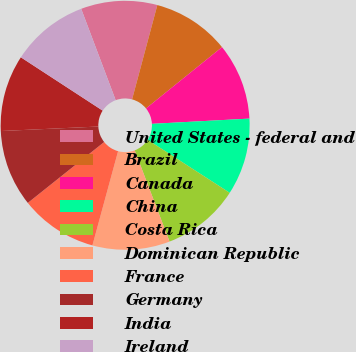<chart> <loc_0><loc_0><loc_500><loc_500><pie_chart><fcel>United States - federal and<fcel>Brazil<fcel>Canada<fcel>China<fcel>Costa Rica<fcel>Dominican Republic<fcel>France<fcel>Germany<fcel>India<fcel>Ireland<nl><fcel>9.91%<fcel>10.03%<fcel>9.95%<fcel>9.98%<fcel>10.07%<fcel>10.04%<fcel>10.05%<fcel>9.98%<fcel>9.93%<fcel>10.06%<nl></chart> 